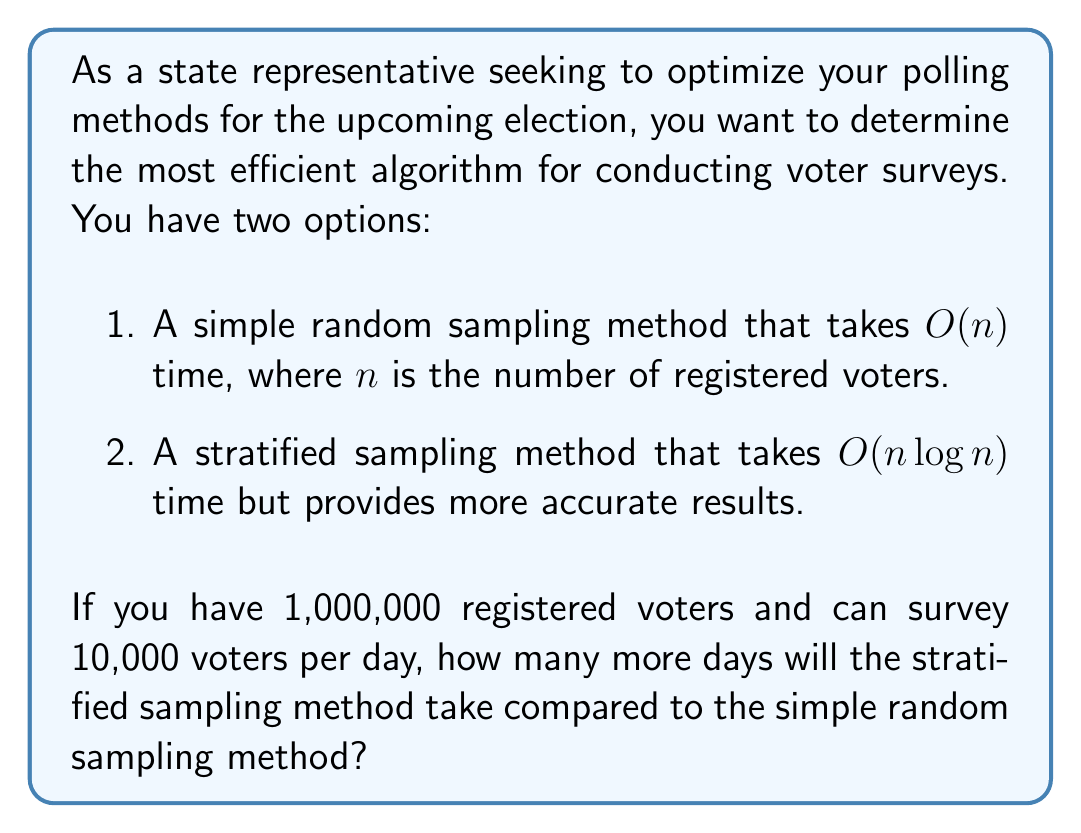Teach me how to tackle this problem. Let's approach this step-by-step:

1) First, we need to calculate the time complexity for each method:

   Simple random sampling: $O(n) = O(1,000,000) = 10^6$
   Stratified sampling: $O(n \log n) = O(1,000,000 \log 1,000,000) = 10^6 \log 10^6$

2) Now, let's calculate $\log 10^6$:
   
   $\log 10^6 = 6 \log 10 \approx 6 * 2.303 = 13.82$

3) So, the time complexity for stratified sampling is approximately:

   $10^6 * 13.82 = 13,820,000$

4) To find the number of days for each method, we divide by the daily survey capacity:

   Simple random sampling: $\frac{10^6}{10,000} = 100$ days
   Stratified sampling: $\frac{13,820,000}{10,000} \approx 1,382$ days

5) The difference in days is:

   $1,382 - 100 = 1,282$ days

Therefore, the stratified sampling method will take approximately 1,282 more days than the simple random sampling method.
Answer: 1,282 days 